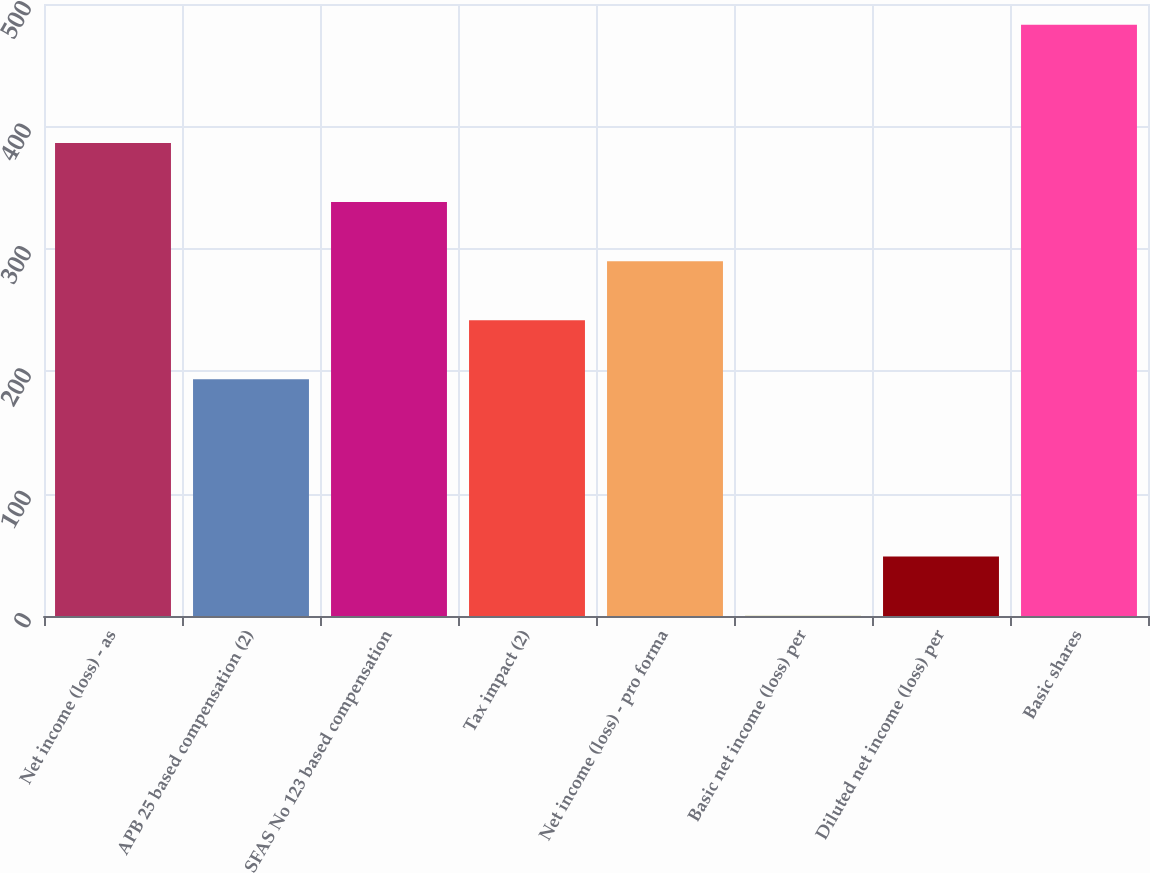Convert chart to OTSL. <chart><loc_0><loc_0><loc_500><loc_500><bar_chart><fcel>Net income (loss) - as<fcel>APB 25 based compensation (2)<fcel>SFAS No 123 based compensation<fcel>Tax impact (2)<fcel>Net income (loss) - pro forma<fcel>Basic net income (loss) per<fcel>Diluted net income (loss) per<fcel>Basic shares<nl><fcel>386.44<fcel>193.36<fcel>338.17<fcel>241.63<fcel>289.9<fcel>0.28<fcel>48.55<fcel>483<nl></chart> 